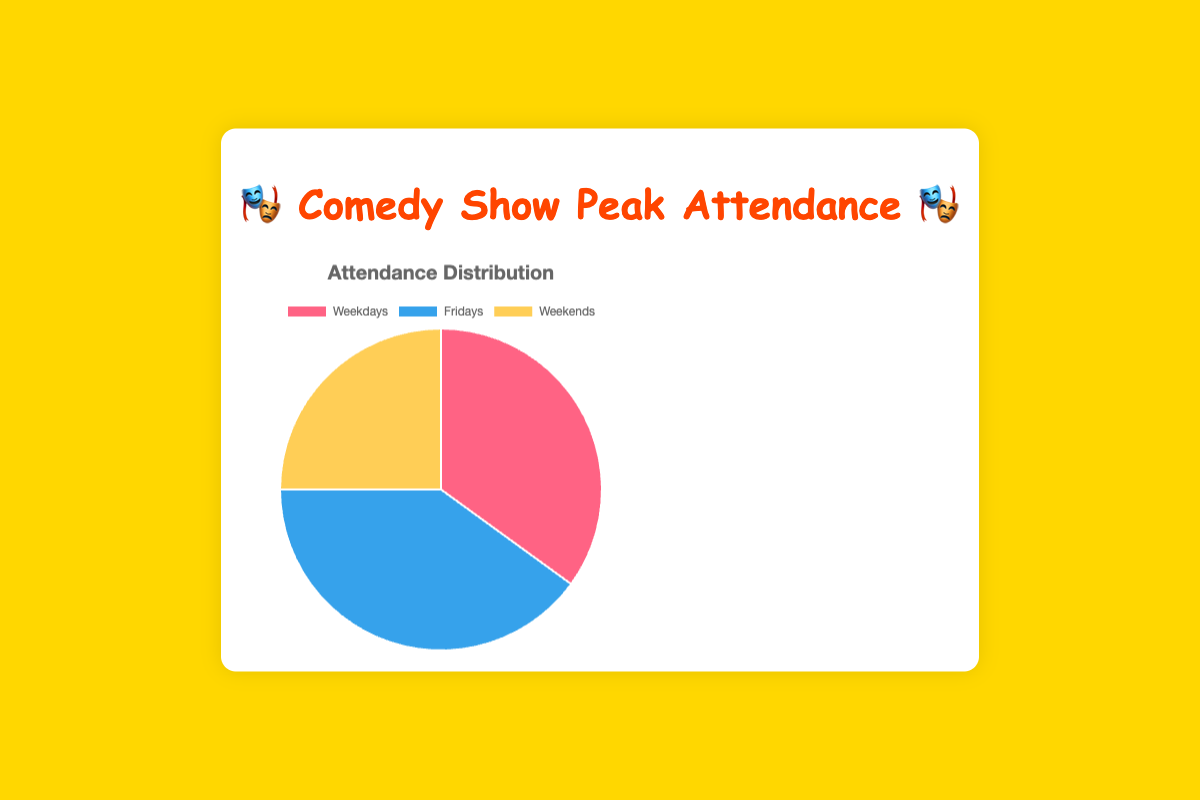which time period has the highest attendance? The figure shows three segments: Weekdays, Fridays, and Weekends. The largest segment represents Fridays with 40%.
Answer: Fridays which time period has the lowest attendance? By looking at the sizes of the segments, Weekends has the smallest part with 25%.
Answer: Weekends what is the difference in attendance between Weekdays and Fridays? The attendance for Weekdays is 35%, and for Fridays, it is 40%. The difference is 40 - 35 = 5%.
Answer: 5% what percentage of total attendance occurs on Weekdays and Weekends combined? The attendance for Weekdays is 35% and for Weekends is 25%. Their combination is 35 + 25 = 60%.
Answer: 60% which segment is represented by the blue color in the figure? The blue segment in the pie chart represents the attendance on Fridays.
Answer: Fridays which two time periods together contribute the same percentage as Fridays alone? Fridays have 40% attendance. Weekdays contribute 35% and Weekends contribute 25%. Combining Weekdays (35%) and Weekends (25%) gives 35 + 25 = 60%, which is more than 40%. The closest match is Weekdays (35%) + a portion of Weekends to make up the remaining 5%.
Answer: Weekdays + a portion of Weekends which color represents the lowest attendance period? The smallest segment in the pie chart is colored yellow, representing the Weekends with 25% attendance.
Answer: Yellow how much more attendance do Fridays have compared to Weekends? Fridays have an attendance of 40% and Weekends have 25%. The difference is 40 - 25 = 15%.
Answer: 15% what is the average attendance for these three time periods? The attendance percentages are 35%, 40%, and 25%. Their average is (35 + 40 + 25) / 3 = 100 / 3 ≈ 33.33%.
Answer: 33.33% if the total attendance were 200 people, how many attended the shows on Fridays? If the total attendance is 200 people, 40% of this number attended on Fridays. 40% of 200 is (40/100) * 200 = 80 people.
Answer: 80 people 